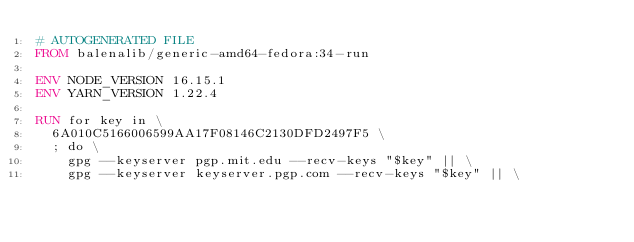Convert code to text. <code><loc_0><loc_0><loc_500><loc_500><_Dockerfile_># AUTOGENERATED FILE
FROM balenalib/generic-amd64-fedora:34-run

ENV NODE_VERSION 16.15.1
ENV YARN_VERSION 1.22.4

RUN for key in \
	6A010C5166006599AA17F08146C2130DFD2497F5 \
	; do \
		gpg --keyserver pgp.mit.edu --recv-keys "$key" || \
		gpg --keyserver keyserver.pgp.com --recv-keys "$key" || \</code> 